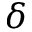<formula> <loc_0><loc_0><loc_500><loc_500>\delta</formula> 